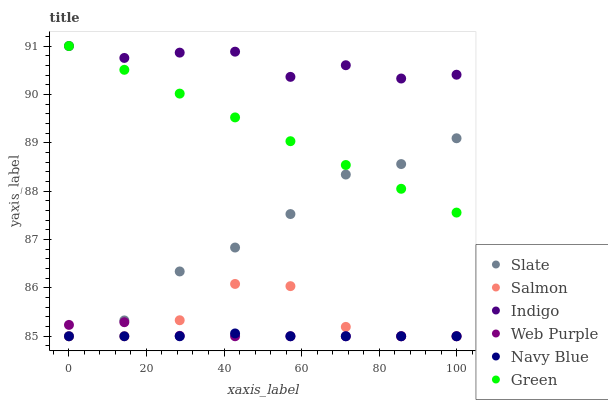Does Navy Blue have the minimum area under the curve?
Answer yes or no. Yes. Does Indigo have the maximum area under the curve?
Answer yes or no. Yes. Does Slate have the minimum area under the curve?
Answer yes or no. No. Does Slate have the maximum area under the curve?
Answer yes or no. No. Is Green the smoothest?
Answer yes or no. Yes. Is Salmon the roughest?
Answer yes or no. Yes. Is Navy Blue the smoothest?
Answer yes or no. No. Is Navy Blue the roughest?
Answer yes or no. No. Does Navy Blue have the lowest value?
Answer yes or no. Yes. Does Green have the lowest value?
Answer yes or no. No. Does Green have the highest value?
Answer yes or no. Yes. Does Slate have the highest value?
Answer yes or no. No. Is Web Purple less than Green?
Answer yes or no. Yes. Is Indigo greater than Web Purple?
Answer yes or no. Yes. Does Slate intersect Web Purple?
Answer yes or no. Yes. Is Slate less than Web Purple?
Answer yes or no. No. Is Slate greater than Web Purple?
Answer yes or no. No. Does Web Purple intersect Green?
Answer yes or no. No. 